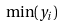Convert formula to latex. <formula><loc_0><loc_0><loc_500><loc_500>\min ( y _ { i } )</formula> 